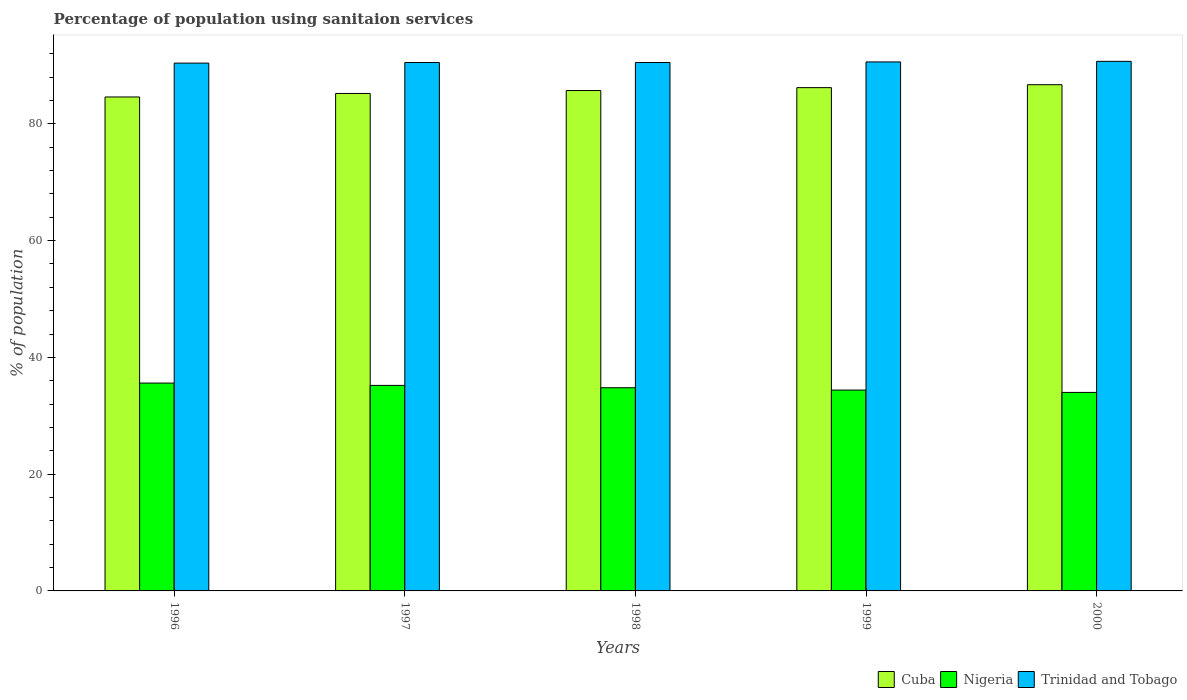How many different coloured bars are there?
Provide a succinct answer. 3. Are the number of bars per tick equal to the number of legend labels?
Keep it short and to the point. Yes. Are the number of bars on each tick of the X-axis equal?
Offer a very short reply. Yes. In how many cases, is the number of bars for a given year not equal to the number of legend labels?
Make the answer very short. 0. What is the percentage of population using sanitaion services in Nigeria in 1997?
Your answer should be very brief. 35.2. Across all years, what is the maximum percentage of population using sanitaion services in Cuba?
Provide a short and direct response. 86.7. Across all years, what is the minimum percentage of population using sanitaion services in Trinidad and Tobago?
Make the answer very short. 90.4. In which year was the percentage of population using sanitaion services in Nigeria minimum?
Your answer should be very brief. 2000. What is the total percentage of population using sanitaion services in Cuba in the graph?
Ensure brevity in your answer.  428.4. What is the difference between the percentage of population using sanitaion services in Trinidad and Tobago in 1999 and that in 2000?
Your answer should be very brief. -0.1. What is the difference between the percentage of population using sanitaion services in Trinidad and Tobago in 1997 and the percentage of population using sanitaion services in Nigeria in 1996?
Your response must be concise. 54.9. What is the average percentage of population using sanitaion services in Trinidad and Tobago per year?
Offer a terse response. 90.54. In the year 1997, what is the difference between the percentage of population using sanitaion services in Nigeria and percentage of population using sanitaion services in Cuba?
Ensure brevity in your answer.  -50. What is the ratio of the percentage of population using sanitaion services in Trinidad and Tobago in 1996 to that in 1999?
Your answer should be compact. 1. What is the difference between the highest and the second highest percentage of population using sanitaion services in Nigeria?
Provide a succinct answer. 0.4. What is the difference between the highest and the lowest percentage of population using sanitaion services in Trinidad and Tobago?
Your response must be concise. 0.3. What does the 1st bar from the left in 1996 represents?
Your answer should be compact. Cuba. What does the 1st bar from the right in 1996 represents?
Offer a terse response. Trinidad and Tobago. Is it the case that in every year, the sum of the percentage of population using sanitaion services in Nigeria and percentage of population using sanitaion services in Cuba is greater than the percentage of population using sanitaion services in Trinidad and Tobago?
Your answer should be very brief. Yes. How many bars are there?
Ensure brevity in your answer.  15. What is the difference between two consecutive major ticks on the Y-axis?
Make the answer very short. 20. Are the values on the major ticks of Y-axis written in scientific E-notation?
Ensure brevity in your answer.  No. Does the graph contain grids?
Make the answer very short. No. What is the title of the graph?
Your response must be concise. Percentage of population using sanitaion services. What is the label or title of the Y-axis?
Offer a very short reply. % of population. What is the % of population of Cuba in 1996?
Provide a succinct answer. 84.6. What is the % of population of Nigeria in 1996?
Your answer should be very brief. 35.6. What is the % of population of Trinidad and Tobago in 1996?
Keep it short and to the point. 90.4. What is the % of population in Cuba in 1997?
Offer a very short reply. 85.2. What is the % of population in Nigeria in 1997?
Offer a terse response. 35.2. What is the % of population of Trinidad and Tobago in 1997?
Ensure brevity in your answer.  90.5. What is the % of population in Cuba in 1998?
Ensure brevity in your answer.  85.7. What is the % of population of Nigeria in 1998?
Provide a short and direct response. 34.8. What is the % of population of Trinidad and Tobago in 1998?
Ensure brevity in your answer.  90.5. What is the % of population of Cuba in 1999?
Give a very brief answer. 86.2. What is the % of population of Nigeria in 1999?
Offer a terse response. 34.4. What is the % of population of Trinidad and Tobago in 1999?
Keep it short and to the point. 90.6. What is the % of population of Cuba in 2000?
Provide a short and direct response. 86.7. What is the % of population of Trinidad and Tobago in 2000?
Keep it short and to the point. 90.7. Across all years, what is the maximum % of population in Cuba?
Keep it short and to the point. 86.7. Across all years, what is the maximum % of population of Nigeria?
Your answer should be very brief. 35.6. Across all years, what is the maximum % of population in Trinidad and Tobago?
Give a very brief answer. 90.7. Across all years, what is the minimum % of population in Cuba?
Make the answer very short. 84.6. Across all years, what is the minimum % of population in Trinidad and Tobago?
Keep it short and to the point. 90.4. What is the total % of population of Cuba in the graph?
Your answer should be very brief. 428.4. What is the total % of population in Nigeria in the graph?
Ensure brevity in your answer.  174. What is the total % of population of Trinidad and Tobago in the graph?
Your response must be concise. 452.7. What is the difference between the % of population of Cuba in 1996 and that in 1997?
Offer a terse response. -0.6. What is the difference between the % of population of Nigeria in 1996 and that in 1997?
Your answer should be compact. 0.4. What is the difference between the % of population in Trinidad and Tobago in 1996 and that in 1997?
Your answer should be compact. -0.1. What is the difference between the % of population of Cuba in 1996 and that in 1998?
Provide a short and direct response. -1.1. What is the difference between the % of population of Cuba in 1996 and that in 1999?
Your answer should be very brief. -1.6. What is the difference between the % of population of Nigeria in 1996 and that in 1999?
Provide a succinct answer. 1.2. What is the difference between the % of population in Trinidad and Tobago in 1996 and that in 1999?
Provide a succinct answer. -0.2. What is the difference between the % of population of Cuba in 1996 and that in 2000?
Your answer should be compact. -2.1. What is the difference between the % of population in Trinidad and Tobago in 1996 and that in 2000?
Ensure brevity in your answer.  -0.3. What is the difference between the % of population of Nigeria in 1997 and that in 1998?
Give a very brief answer. 0.4. What is the difference between the % of population in Trinidad and Tobago in 1997 and that in 1998?
Offer a very short reply. 0. What is the difference between the % of population of Nigeria in 1997 and that in 1999?
Give a very brief answer. 0.8. What is the difference between the % of population in Nigeria in 1997 and that in 2000?
Provide a short and direct response. 1.2. What is the difference between the % of population in Nigeria in 1998 and that in 2000?
Offer a terse response. 0.8. What is the difference between the % of population in Cuba in 1999 and that in 2000?
Your answer should be compact. -0.5. What is the difference between the % of population of Trinidad and Tobago in 1999 and that in 2000?
Your answer should be very brief. -0.1. What is the difference between the % of population in Cuba in 1996 and the % of population in Nigeria in 1997?
Make the answer very short. 49.4. What is the difference between the % of population of Nigeria in 1996 and the % of population of Trinidad and Tobago in 1997?
Your answer should be compact. -54.9. What is the difference between the % of population in Cuba in 1996 and the % of population in Nigeria in 1998?
Offer a very short reply. 49.8. What is the difference between the % of population in Cuba in 1996 and the % of population in Trinidad and Tobago in 1998?
Provide a succinct answer. -5.9. What is the difference between the % of population of Nigeria in 1996 and the % of population of Trinidad and Tobago in 1998?
Your response must be concise. -54.9. What is the difference between the % of population of Cuba in 1996 and the % of population of Nigeria in 1999?
Provide a short and direct response. 50.2. What is the difference between the % of population in Cuba in 1996 and the % of population in Trinidad and Tobago in 1999?
Keep it short and to the point. -6. What is the difference between the % of population of Nigeria in 1996 and the % of population of Trinidad and Tobago in 1999?
Your response must be concise. -55. What is the difference between the % of population of Cuba in 1996 and the % of population of Nigeria in 2000?
Your response must be concise. 50.6. What is the difference between the % of population of Cuba in 1996 and the % of population of Trinidad and Tobago in 2000?
Give a very brief answer. -6.1. What is the difference between the % of population in Nigeria in 1996 and the % of population in Trinidad and Tobago in 2000?
Your response must be concise. -55.1. What is the difference between the % of population of Cuba in 1997 and the % of population of Nigeria in 1998?
Make the answer very short. 50.4. What is the difference between the % of population of Cuba in 1997 and the % of population of Trinidad and Tobago in 1998?
Your response must be concise. -5.3. What is the difference between the % of population in Nigeria in 1997 and the % of population in Trinidad and Tobago in 1998?
Provide a short and direct response. -55.3. What is the difference between the % of population in Cuba in 1997 and the % of population in Nigeria in 1999?
Provide a succinct answer. 50.8. What is the difference between the % of population of Cuba in 1997 and the % of population of Trinidad and Tobago in 1999?
Provide a short and direct response. -5.4. What is the difference between the % of population of Nigeria in 1997 and the % of population of Trinidad and Tobago in 1999?
Your response must be concise. -55.4. What is the difference between the % of population of Cuba in 1997 and the % of population of Nigeria in 2000?
Provide a succinct answer. 51.2. What is the difference between the % of population in Nigeria in 1997 and the % of population in Trinidad and Tobago in 2000?
Keep it short and to the point. -55.5. What is the difference between the % of population in Cuba in 1998 and the % of population in Nigeria in 1999?
Provide a succinct answer. 51.3. What is the difference between the % of population of Cuba in 1998 and the % of population of Trinidad and Tobago in 1999?
Your answer should be compact. -4.9. What is the difference between the % of population of Nigeria in 1998 and the % of population of Trinidad and Tobago in 1999?
Offer a terse response. -55.8. What is the difference between the % of population of Cuba in 1998 and the % of population of Nigeria in 2000?
Give a very brief answer. 51.7. What is the difference between the % of population of Cuba in 1998 and the % of population of Trinidad and Tobago in 2000?
Keep it short and to the point. -5. What is the difference between the % of population of Nigeria in 1998 and the % of population of Trinidad and Tobago in 2000?
Your answer should be very brief. -55.9. What is the difference between the % of population of Cuba in 1999 and the % of population of Nigeria in 2000?
Offer a terse response. 52.2. What is the difference between the % of population in Cuba in 1999 and the % of population in Trinidad and Tobago in 2000?
Your answer should be compact. -4.5. What is the difference between the % of population of Nigeria in 1999 and the % of population of Trinidad and Tobago in 2000?
Provide a short and direct response. -56.3. What is the average % of population of Cuba per year?
Your answer should be compact. 85.68. What is the average % of population in Nigeria per year?
Your answer should be very brief. 34.8. What is the average % of population in Trinidad and Tobago per year?
Give a very brief answer. 90.54. In the year 1996, what is the difference between the % of population in Cuba and % of population in Nigeria?
Your answer should be very brief. 49. In the year 1996, what is the difference between the % of population of Cuba and % of population of Trinidad and Tobago?
Offer a terse response. -5.8. In the year 1996, what is the difference between the % of population of Nigeria and % of population of Trinidad and Tobago?
Provide a short and direct response. -54.8. In the year 1997, what is the difference between the % of population in Cuba and % of population in Trinidad and Tobago?
Ensure brevity in your answer.  -5.3. In the year 1997, what is the difference between the % of population of Nigeria and % of population of Trinidad and Tobago?
Give a very brief answer. -55.3. In the year 1998, what is the difference between the % of population in Cuba and % of population in Nigeria?
Keep it short and to the point. 50.9. In the year 1998, what is the difference between the % of population of Nigeria and % of population of Trinidad and Tobago?
Offer a very short reply. -55.7. In the year 1999, what is the difference between the % of population in Cuba and % of population in Nigeria?
Offer a terse response. 51.8. In the year 1999, what is the difference between the % of population in Nigeria and % of population in Trinidad and Tobago?
Make the answer very short. -56.2. In the year 2000, what is the difference between the % of population of Cuba and % of population of Nigeria?
Provide a short and direct response. 52.7. In the year 2000, what is the difference between the % of population of Nigeria and % of population of Trinidad and Tobago?
Provide a succinct answer. -56.7. What is the ratio of the % of population in Cuba in 1996 to that in 1997?
Offer a very short reply. 0.99. What is the ratio of the % of population of Nigeria in 1996 to that in 1997?
Give a very brief answer. 1.01. What is the ratio of the % of population of Trinidad and Tobago in 1996 to that in 1997?
Offer a very short reply. 1. What is the ratio of the % of population in Cuba in 1996 to that in 1998?
Your answer should be very brief. 0.99. What is the ratio of the % of population of Nigeria in 1996 to that in 1998?
Offer a very short reply. 1.02. What is the ratio of the % of population in Cuba in 1996 to that in 1999?
Offer a very short reply. 0.98. What is the ratio of the % of population in Nigeria in 1996 to that in 1999?
Ensure brevity in your answer.  1.03. What is the ratio of the % of population of Cuba in 1996 to that in 2000?
Your answer should be compact. 0.98. What is the ratio of the % of population of Nigeria in 1996 to that in 2000?
Your answer should be very brief. 1.05. What is the ratio of the % of population of Nigeria in 1997 to that in 1998?
Offer a terse response. 1.01. What is the ratio of the % of population of Cuba in 1997 to that in 1999?
Provide a succinct answer. 0.99. What is the ratio of the % of population of Nigeria in 1997 to that in 1999?
Keep it short and to the point. 1.02. What is the ratio of the % of population in Cuba in 1997 to that in 2000?
Give a very brief answer. 0.98. What is the ratio of the % of population of Nigeria in 1997 to that in 2000?
Give a very brief answer. 1.04. What is the ratio of the % of population of Trinidad and Tobago in 1997 to that in 2000?
Ensure brevity in your answer.  1. What is the ratio of the % of population in Nigeria in 1998 to that in 1999?
Provide a short and direct response. 1.01. What is the ratio of the % of population in Nigeria in 1998 to that in 2000?
Keep it short and to the point. 1.02. What is the ratio of the % of population of Cuba in 1999 to that in 2000?
Offer a terse response. 0.99. What is the ratio of the % of population of Nigeria in 1999 to that in 2000?
Your answer should be very brief. 1.01. What is the difference between the highest and the second highest % of population in Trinidad and Tobago?
Your answer should be very brief. 0.1. What is the difference between the highest and the lowest % of population in Nigeria?
Offer a very short reply. 1.6. 